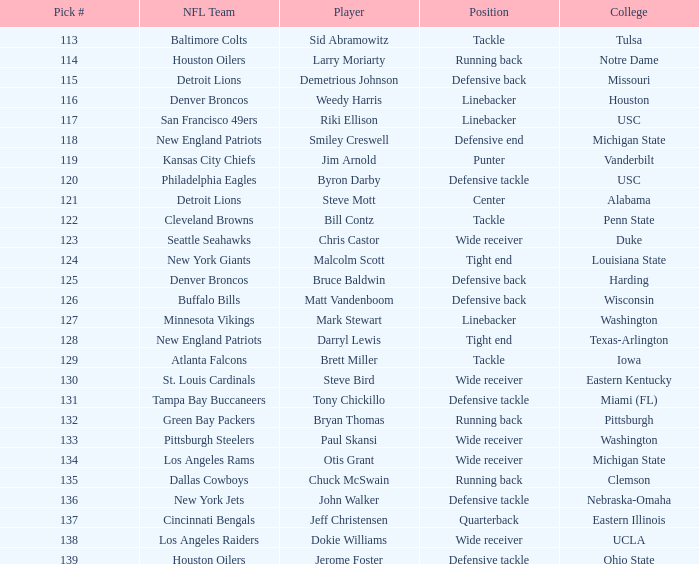What draft number was acquired by the buffalo bills? 126.0. 